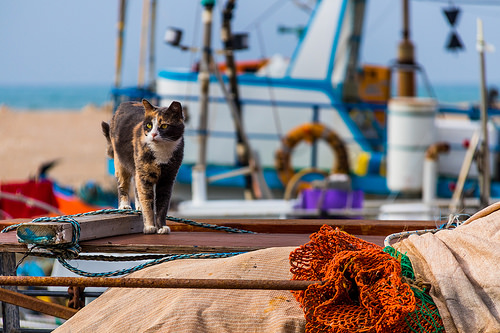<image>
Is there a cat next to the poll? No. The cat is not positioned next to the poll. They are located in different areas of the scene. 